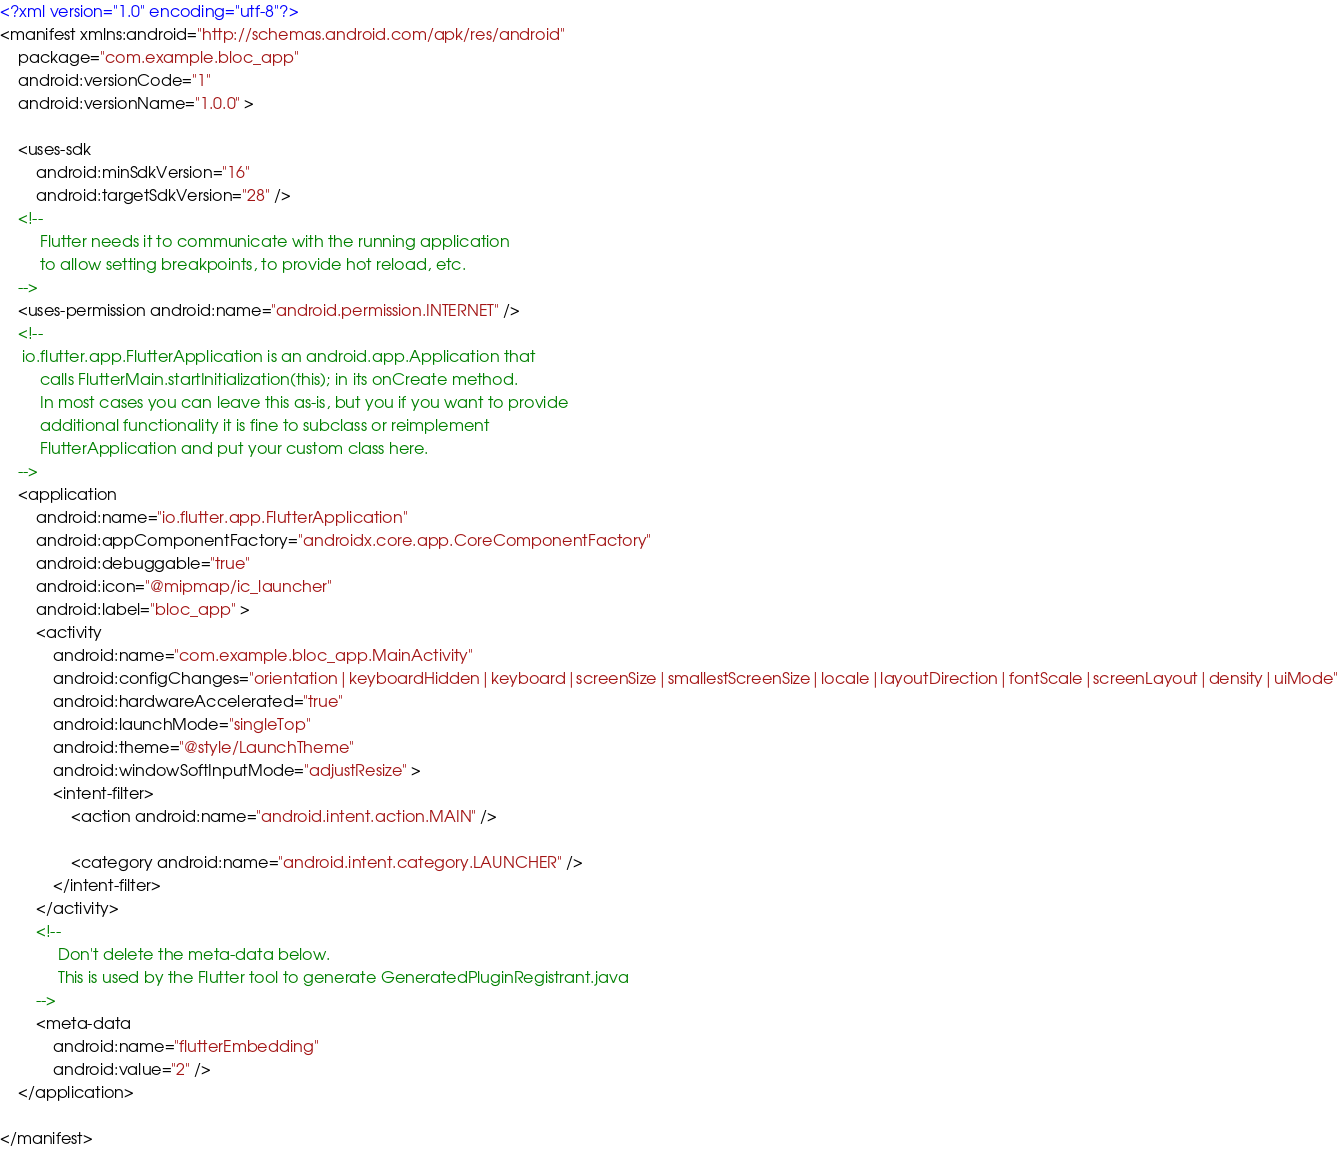Convert code to text. <code><loc_0><loc_0><loc_500><loc_500><_XML_><?xml version="1.0" encoding="utf-8"?>
<manifest xmlns:android="http://schemas.android.com/apk/res/android"
    package="com.example.bloc_app"
    android:versionCode="1"
    android:versionName="1.0.0" >

    <uses-sdk
        android:minSdkVersion="16"
        android:targetSdkVersion="28" />
    <!--
         Flutter needs it to communicate with the running application
         to allow setting breakpoints, to provide hot reload, etc.
    -->
    <uses-permission android:name="android.permission.INTERNET" />
    <!--
     io.flutter.app.FlutterApplication is an android.app.Application that
         calls FlutterMain.startInitialization(this); in its onCreate method.
         In most cases you can leave this as-is, but you if you want to provide
         additional functionality it is fine to subclass or reimplement
         FlutterApplication and put your custom class here.
    -->
    <application
        android:name="io.flutter.app.FlutterApplication"
        android:appComponentFactory="androidx.core.app.CoreComponentFactory"
        android:debuggable="true"
        android:icon="@mipmap/ic_launcher"
        android:label="bloc_app" >
        <activity
            android:name="com.example.bloc_app.MainActivity"
            android:configChanges="orientation|keyboardHidden|keyboard|screenSize|smallestScreenSize|locale|layoutDirection|fontScale|screenLayout|density|uiMode"
            android:hardwareAccelerated="true"
            android:launchMode="singleTop"
            android:theme="@style/LaunchTheme"
            android:windowSoftInputMode="adjustResize" >
            <intent-filter>
                <action android:name="android.intent.action.MAIN" />

                <category android:name="android.intent.category.LAUNCHER" />
            </intent-filter>
        </activity>
        <!--
             Don't delete the meta-data below.
             This is used by the Flutter tool to generate GeneratedPluginRegistrant.java
        -->
        <meta-data
            android:name="flutterEmbedding"
            android:value="2" />
    </application>

</manifest></code> 